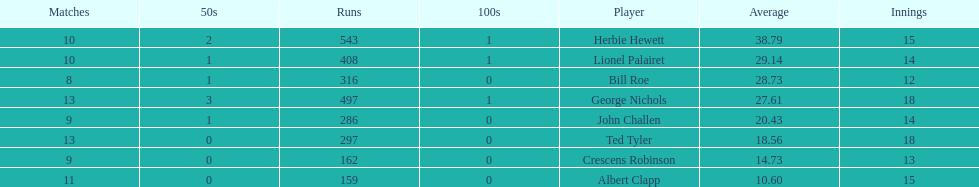Can you mention a player who has taken part in a maximum of 13 innings? Bill Roe. 